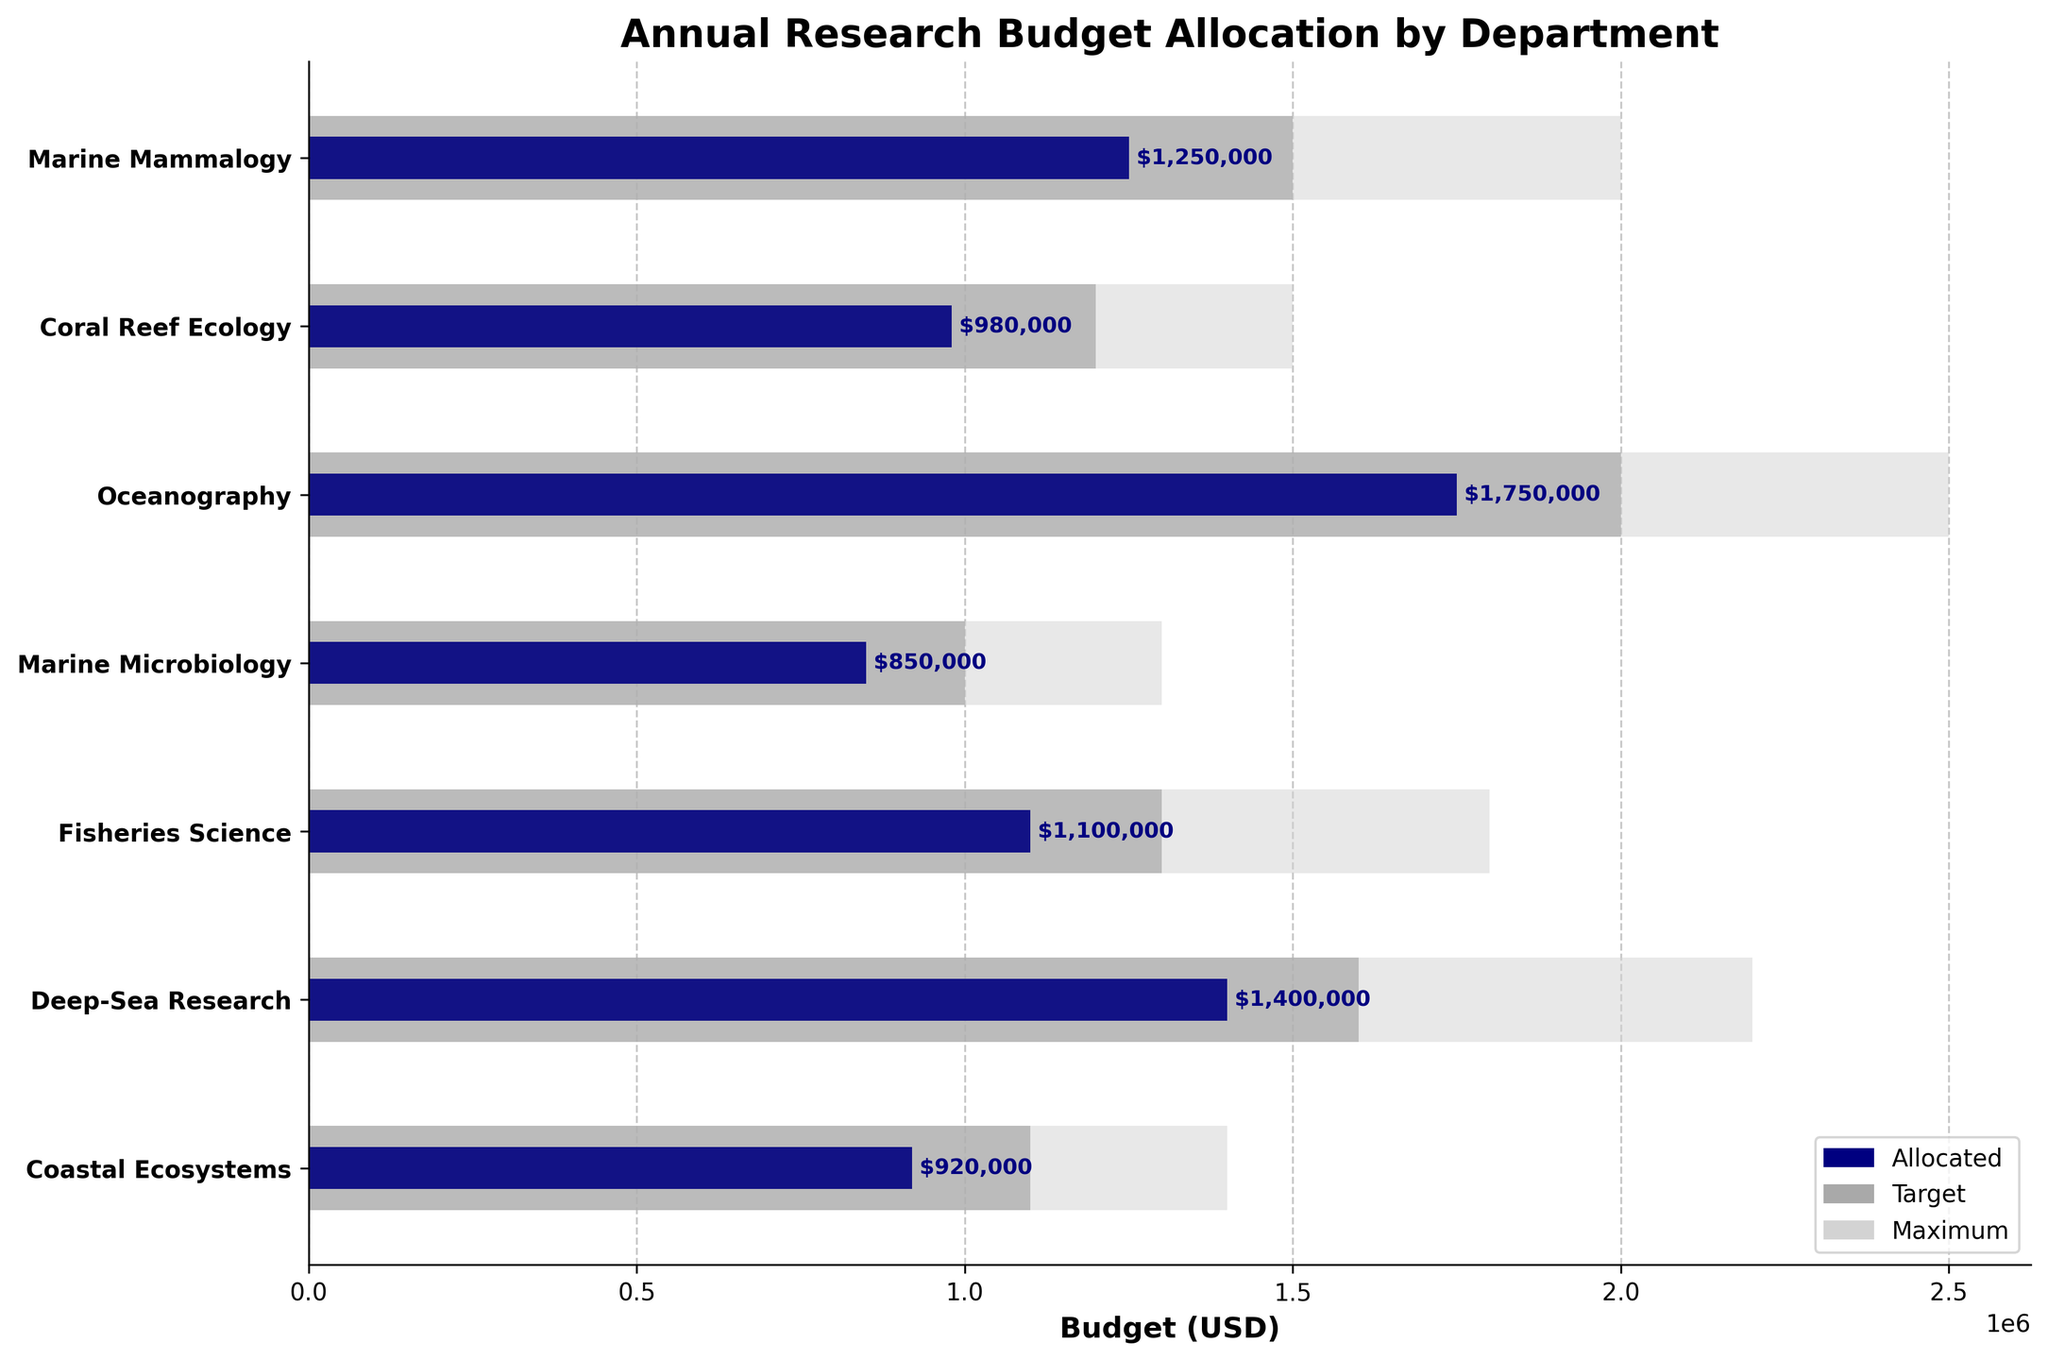Which department received the highest allocated budget? Compare the navy blue bars representing the allocated budget for each department. The Oceanography department has the longest navy blue bar, indicating the highest allocated budget.
Answer: Oceanography Which department's allocated budget is closest to its target budget? Compare the lengths of the navy blue bars (allocated budget) to the dark grey bars (target budget). The Marine Microbiology department's allocated budget is nearly equal to its target budget.
Answer: Marine Microbiology How many departments exceed their target budget? Count the number of departments where the navy blue bar extends beyond the end of the dark grey bar. No department exceeds its target budget.
Answer: 0 What is the difference between the maximum and allocated budgets for Deep-Sea Research? Locate the bars for Deep-Sea Research. Subtract the length of the navy blue bar (allocated budget) from the light grey bar (maximum budget), i.e., 2200000 - 1400000.
Answer: 800000 Which department has the smallest allocated budget relative to its maximum budget? Determine the ratio of allocated to maximum budget for each department. The department with the smallest ratio is Marine Microbiology (850000 / 1300000).
Answer: Marine Microbiology If additional funds are required to meet the target budgets for all departments, how much extra funding is needed in total? Subtract the allocated budget from the target budget for each department, then sum these differences: (1500000 - 1250000) + (1200000 - 980000) + (2000000 - 1750000) + (1000000 - 850000) + (1300000 - 1100000) + (1600000 - 1400000) + (1100000 - 920000).
Answer: 980000 In which department is the allocated budget furthest below the maximum budget? Compute the difference between the allocated and maximum budget for each department. The largest difference is in the Oceanography department (2500000 - 1750000).
Answer: Oceanography What is the combined allocated budget for Coastal Ecosystems and Coral Reef Ecology? Add the allocated budgets of Coastal Ecosystems (920000) and Coral Reef Ecology (980000).
Answer: 1900000 Is there any department where the allocated budget is above its target but below its maximum budget? Observe if the navy blue bar falls between the end of the dark grey bar and the end of the light grey bar for any department. There isn't any such department.
Answer: No 